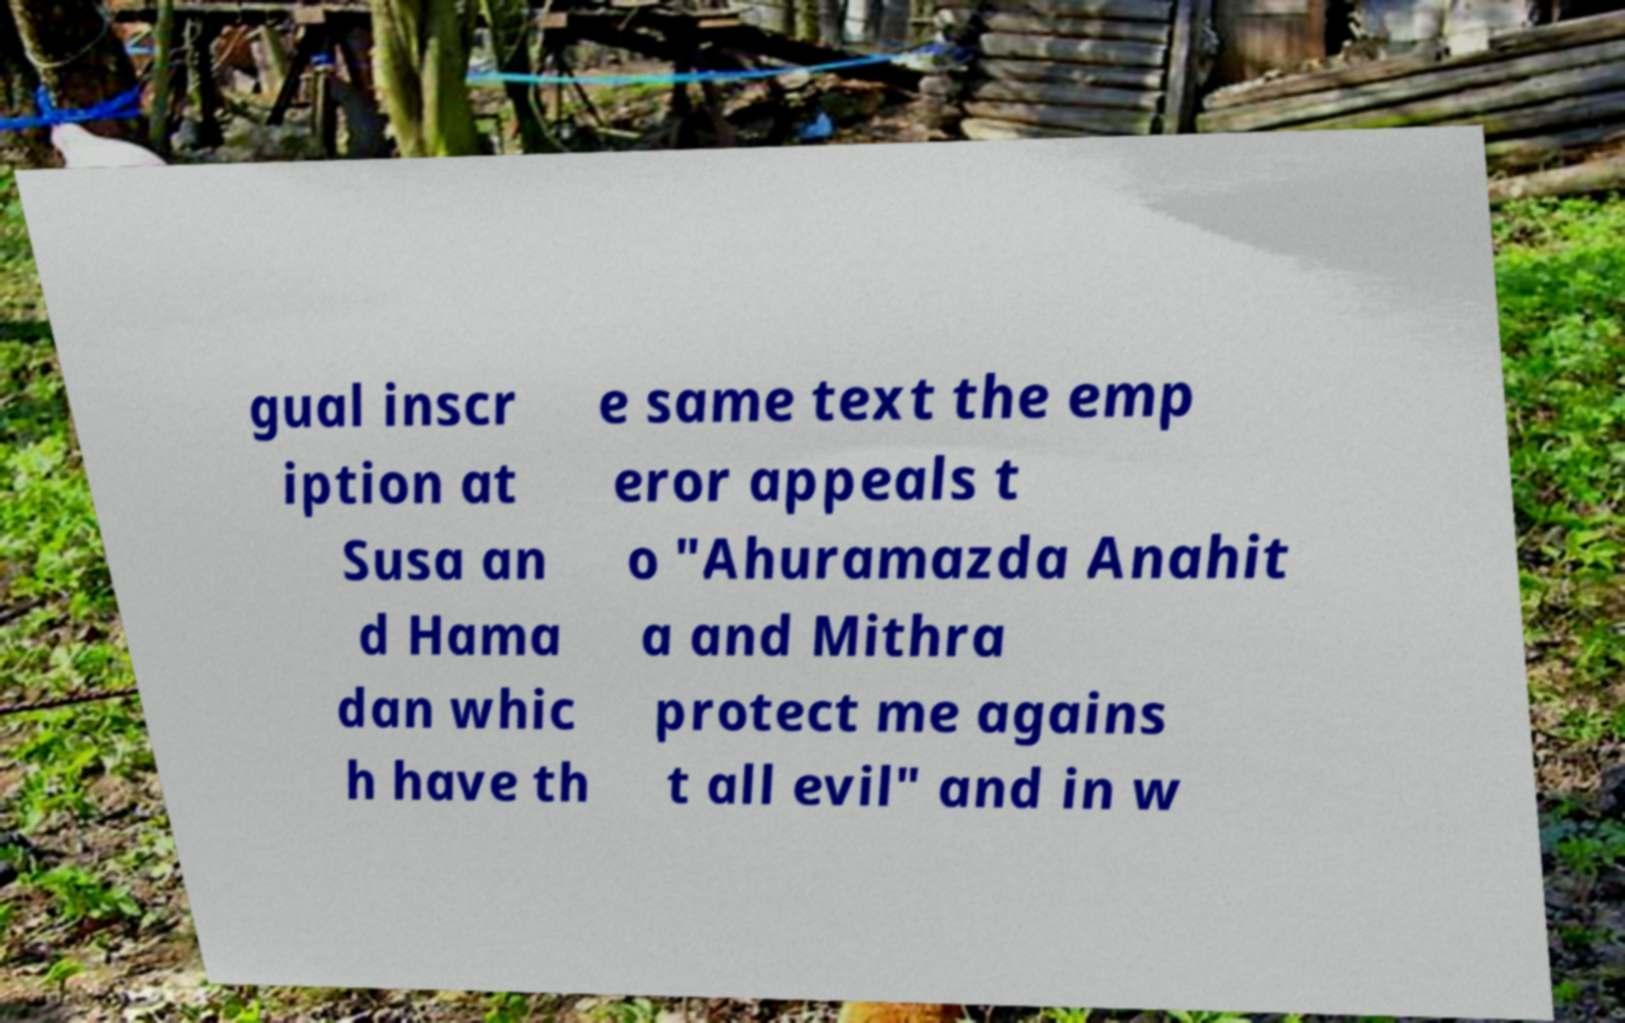Please identify and transcribe the text found in this image. gual inscr iption at Susa an d Hama dan whic h have th e same text the emp eror appeals t o "Ahuramazda Anahit a and Mithra protect me agains t all evil" and in w 